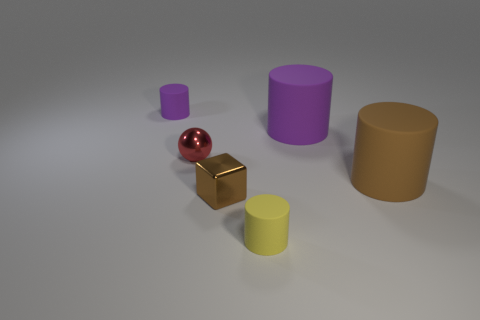What size is the rubber cylinder that is both behind the brown shiny cube and in front of the sphere?
Keep it short and to the point. Large. There is a big thing that is the same color as the metallic block; what is it made of?
Give a very brief answer. Rubber. There is a brown cube that is the same size as the yellow matte cylinder; what is it made of?
Offer a terse response. Metal. How many things are large matte objects behind the red ball or tiny cylinders that are to the left of the tiny yellow cylinder?
Your answer should be very brief. 2. There is a brown thing that is made of the same material as the large purple cylinder; what size is it?
Offer a terse response. Large. How many matte things are cubes or red cylinders?
Your answer should be compact. 0. The red ball has what size?
Your answer should be compact. Small. Is the red ball the same size as the yellow matte object?
Offer a terse response. Yes. What is the material of the brown object that is in front of the big brown matte thing?
Ensure brevity in your answer.  Metal. Is there a large thing that is in front of the purple rubber object right of the tiny yellow cylinder?
Ensure brevity in your answer.  Yes. 